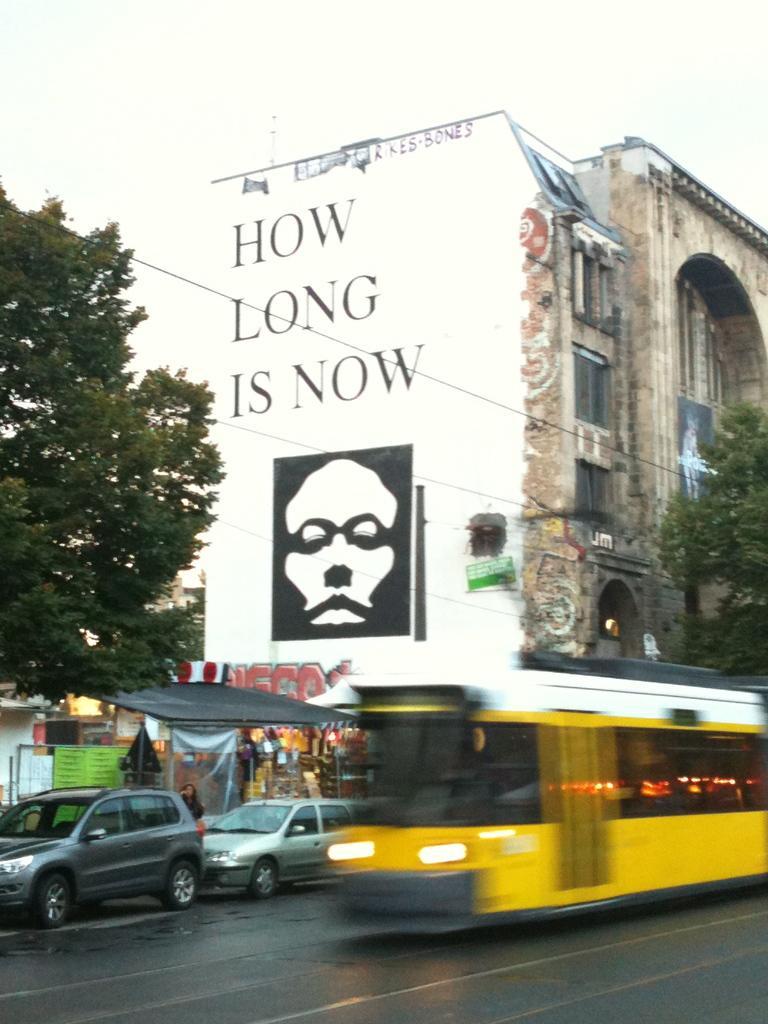Can you describe this image briefly? There is an yellow color vehicle on the road near other two vehicles. In the background, there is a black color tent near a tree. There is a building which is having white color wall. On which, there is a painting, there are trees and there is sky. 